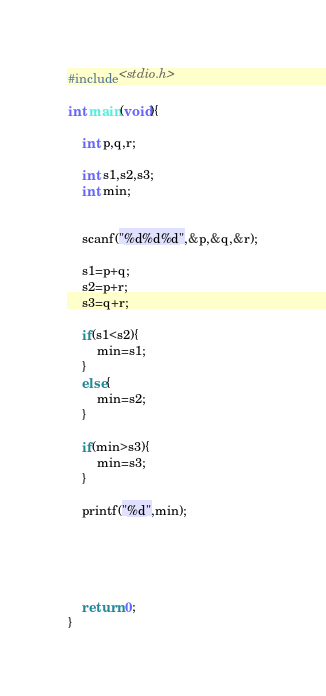Convert code to text. <code><loc_0><loc_0><loc_500><loc_500><_C_>#include<stdio.h>

int main(void){

    int p,q,r;

    int s1,s2,s3;
    int min;


    scanf("%d%d%d",&p,&q,&r);

    s1=p+q;
    s2=p+r;
    s3=q+r;

    if(s1<s2){
        min=s1;
    }
    else{
        min=s2;
    }

    if(min>s3){
        min=s3;
    }
    
    printf("%d",min);
    
    



    return 0;
}</code> 